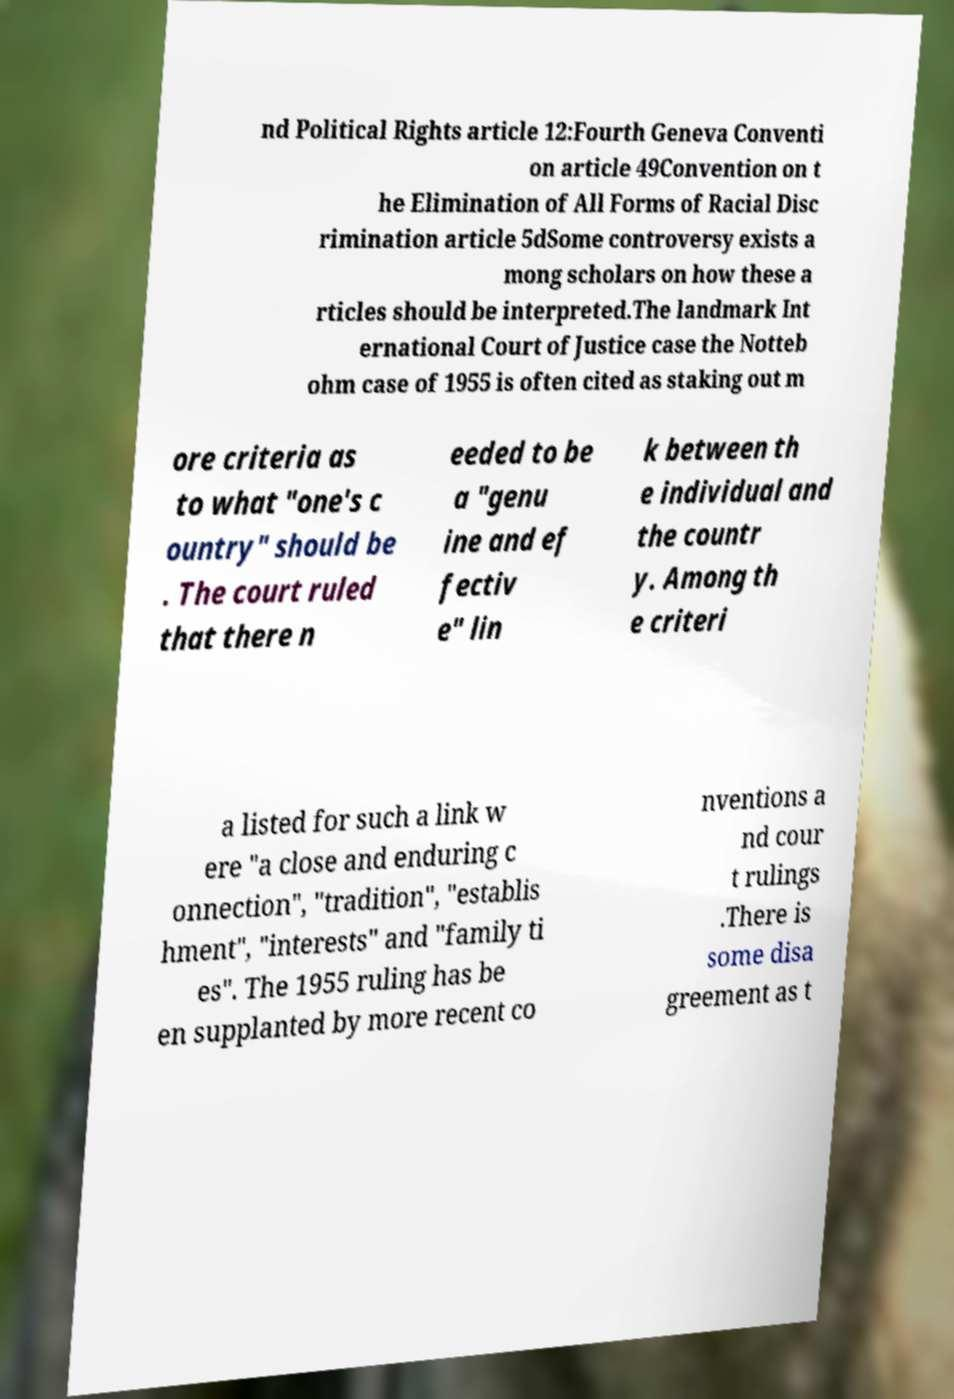Could you assist in decoding the text presented in this image and type it out clearly? nd Political Rights article 12:Fourth Geneva Conventi on article 49Convention on t he Elimination of All Forms of Racial Disc rimination article 5dSome controversy exists a mong scholars on how these a rticles should be interpreted.The landmark Int ernational Court of Justice case the Notteb ohm case of 1955 is often cited as staking out m ore criteria as to what "one's c ountry" should be . The court ruled that there n eeded to be a "genu ine and ef fectiv e" lin k between th e individual and the countr y. Among th e criteri a listed for such a link w ere "a close and enduring c onnection", "tradition", "establis hment", "interests" and "family ti es". The 1955 ruling has be en supplanted by more recent co nventions a nd cour t rulings .There is some disa greement as t 